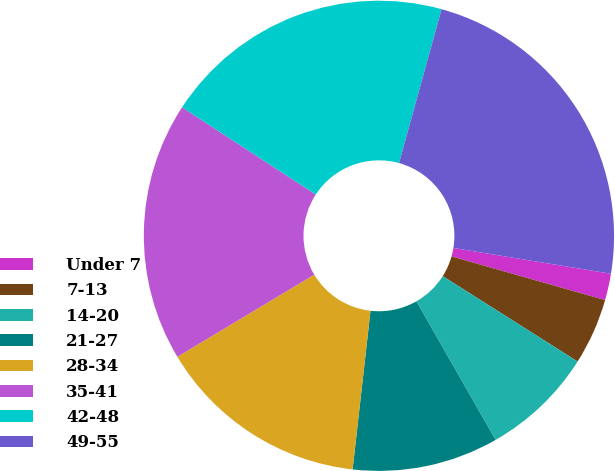Convert chart. <chart><loc_0><loc_0><loc_500><loc_500><pie_chart><fcel>Under 7<fcel>7-13<fcel>14-20<fcel>21-27<fcel>28-34<fcel>35-41<fcel>42-48<fcel>49-55<nl><fcel>1.83%<fcel>4.57%<fcel>7.76%<fcel>10.05%<fcel>14.61%<fcel>17.81%<fcel>20.09%<fcel>23.29%<nl></chart> 